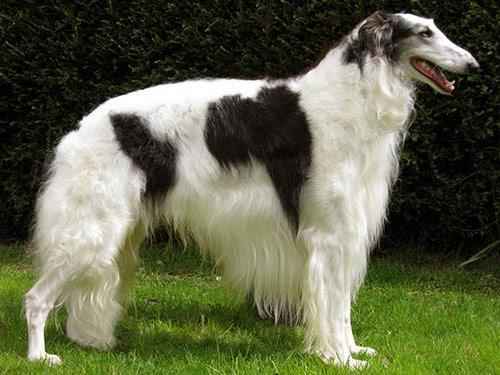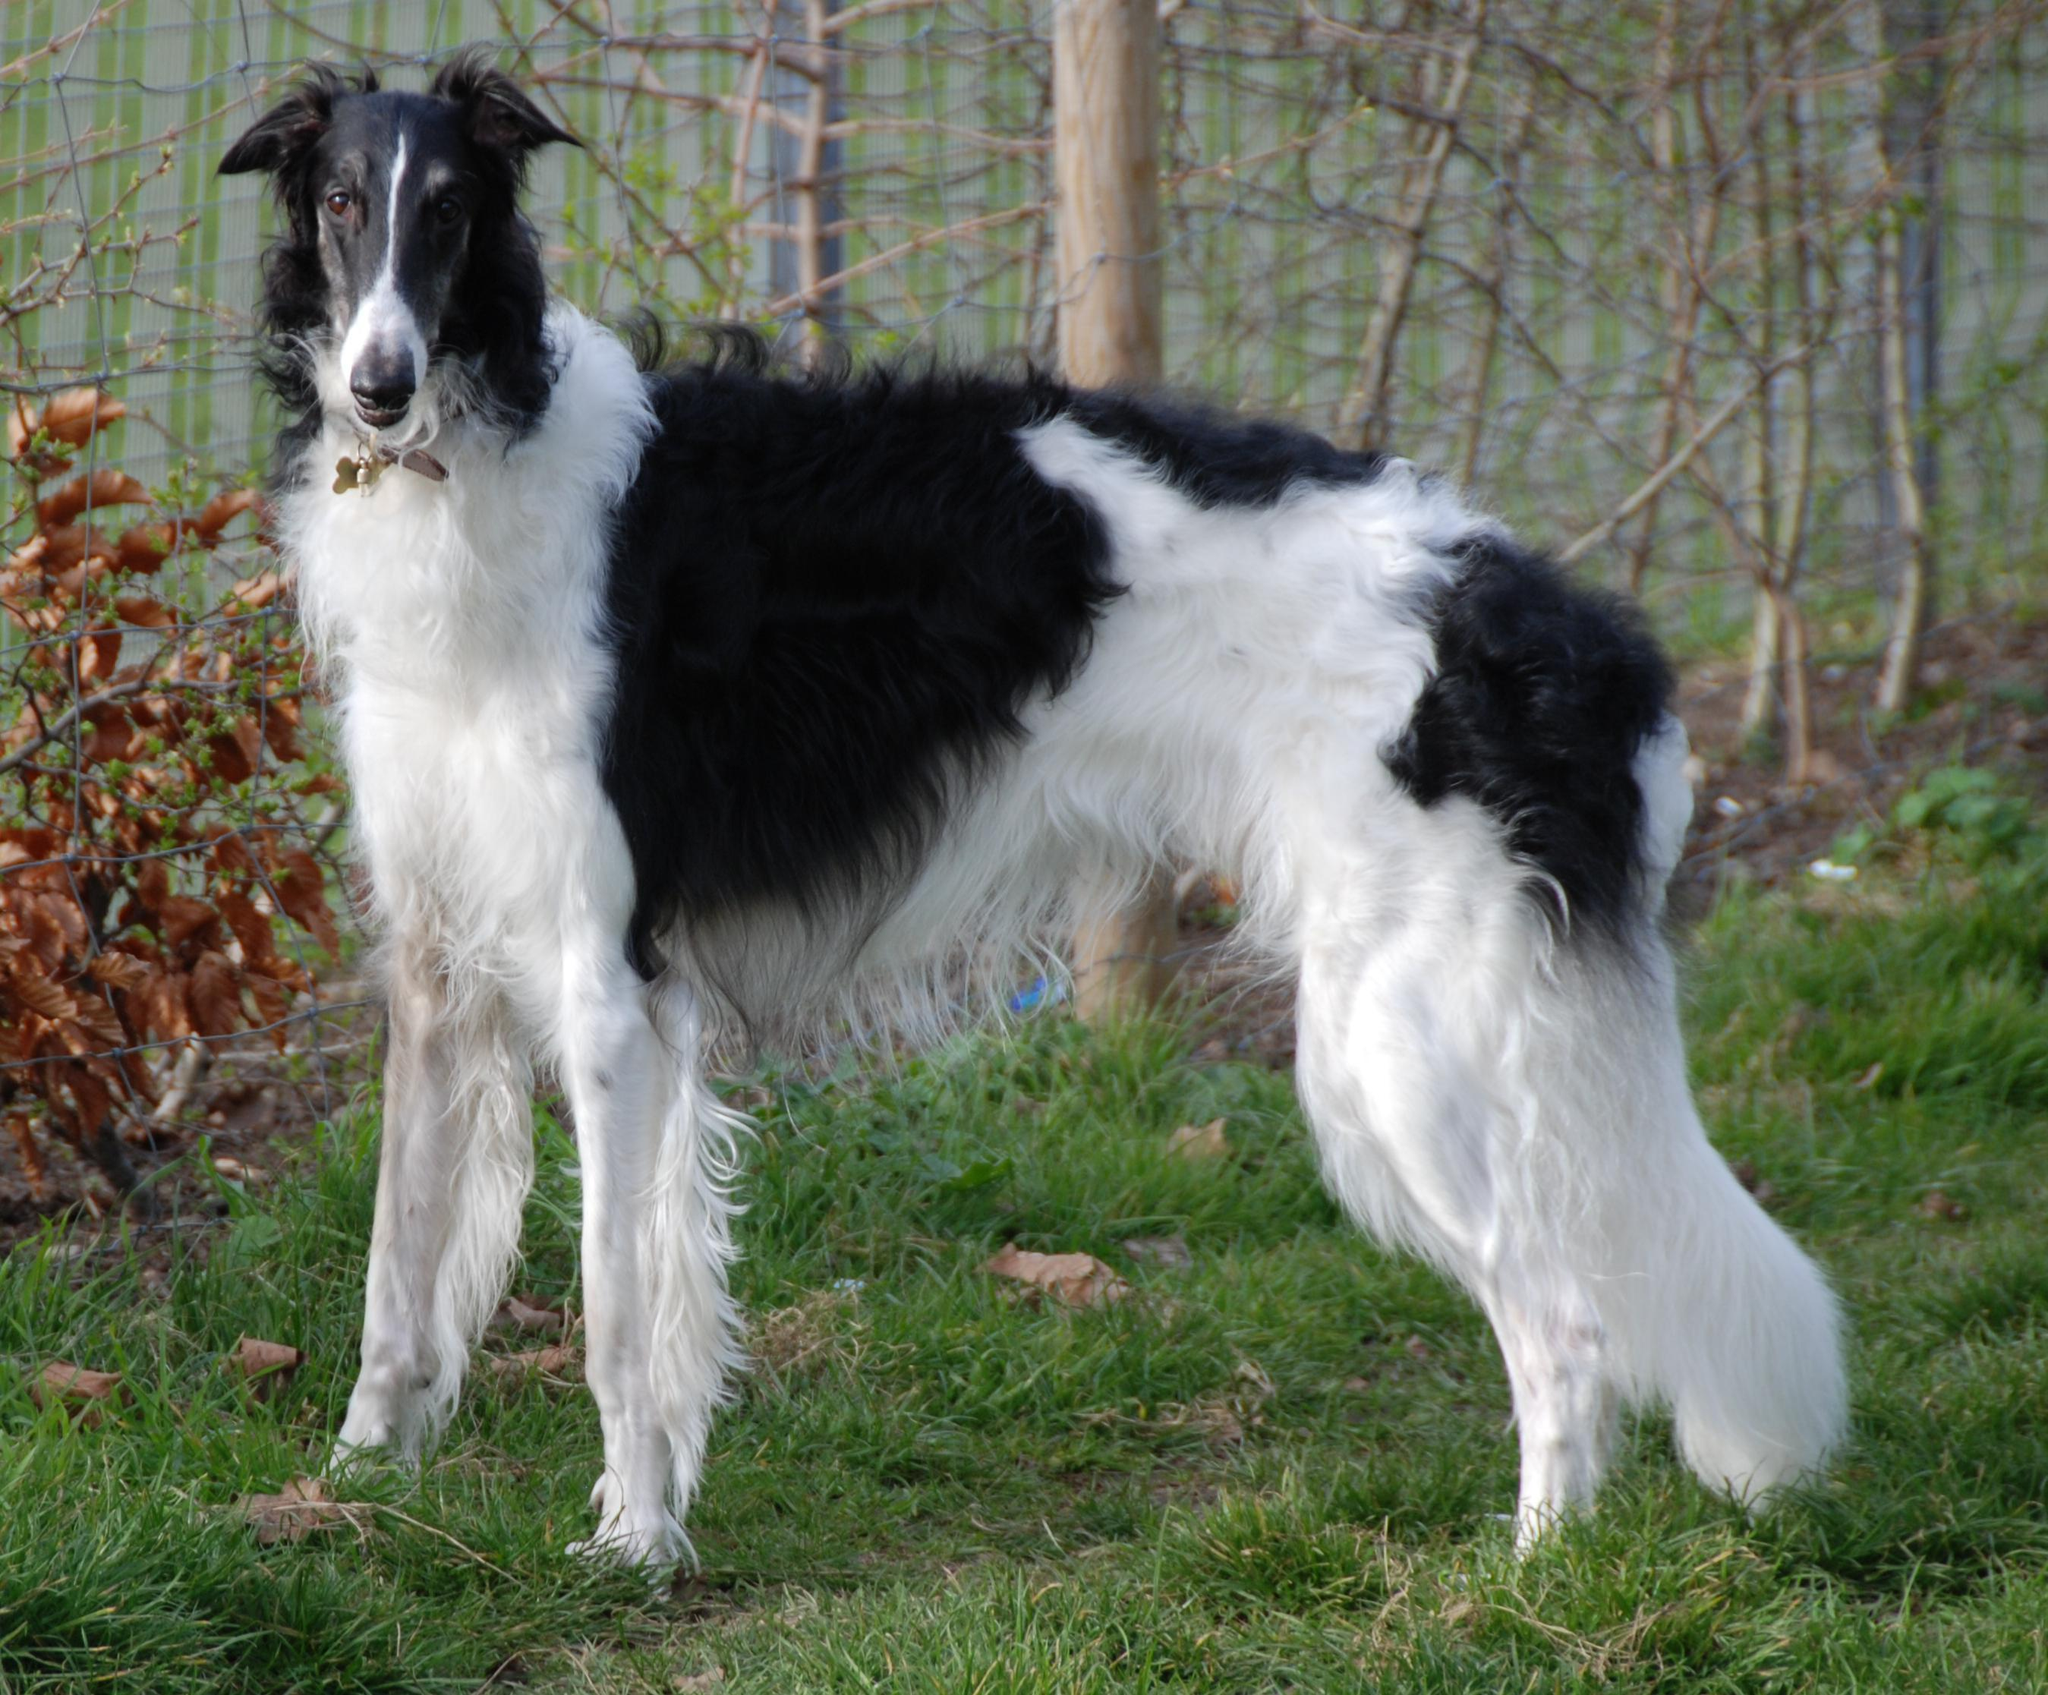The first image is the image on the left, the second image is the image on the right. For the images displayed, is the sentence "There are two dogs total, facing both left and right." factually correct? Answer yes or no. Yes. The first image is the image on the left, the second image is the image on the right. Analyze the images presented: Is the assertion "One dog is facing left and one dog is facing right." valid? Answer yes or no. Yes. 